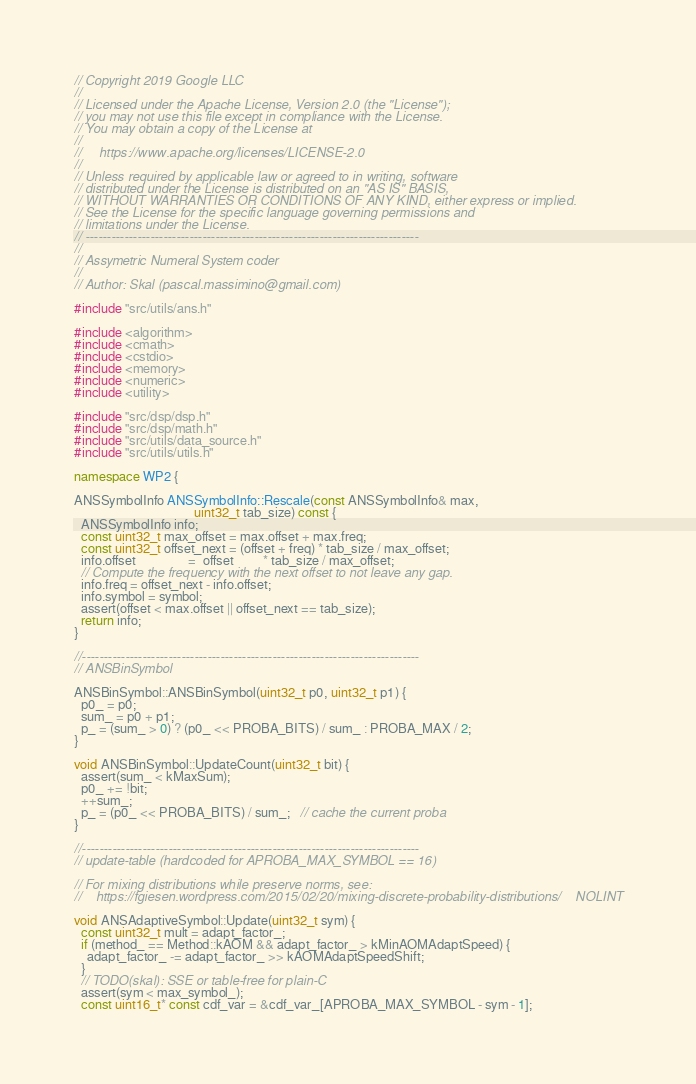<code> <loc_0><loc_0><loc_500><loc_500><_C++_>// Copyright 2019 Google LLC
//
// Licensed under the Apache License, Version 2.0 (the "License");
// you may not use this file except in compliance with the License.
// You may obtain a copy of the License at
//
//     https://www.apache.org/licenses/LICENSE-2.0
//
// Unless required by applicable law or agreed to in writing, software
// distributed under the License is distributed on an "AS IS" BASIS,
// WITHOUT WARRANTIES OR CONDITIONS OF ANY KIND, either express or implied.
// See the License for the specific language governing permissions and
// limitations under the License.
// -----------------------------------------------------------------------------
//
// Assymetric Numeral System coder
//
// Author: Skal (pascal.massimino@gmail.com)

#include "src/utils/ans.h"

#include <algorithm>
#include <cmath>
#include <cstdio>
#include <memory>
#include <numeric>
#include <utility>

#include "src/dsp/dsp.h"
#include "src/dsp/math.h"
#include "src/utils/data_source.h"
#include "src/utils/utils.h"

namespace WP2 {

ANSSymbolInfo ANSSymbolInfo::Rescale(const ANSSymbolInfo& max,
                                     uint32_t tab_size) const {
  ANSSymbolInfo info;
  const uint32_t max_offset = max.offset + max.freq;
  const uint32_t offset_next = (offset + freq) * tab_size / max_offset;
  info.offset                =  offset         * tab_size / max_offset;
  // Compute the frequency with the next offset to not leave any gap.
  info.freq = offset_next - info.offset;
  info.symbol = symbol;
  assert(offset < max.offset || offset_next == tab_size);
  return info;
}

//------------------------------------------------------------------------------
// ANSBinSymbol

ANSBinSymbol::ANSBinSymbol(uint32_t p0, uint32_t p1) {
  p0_ = p0;
  sum_ = p0 + p1;
  p_ = (sum_ > 0) ? (p0_ << PROBA_BITS) / sum_ : PROBA_MAX / 2;
}

void ANSBinSymbol::UpdateCount(uint32_t bit) {
  assert(sum_ < kMaxSum);
  p0_ += !bit;
  ++sum_;
  p_ = (p0_ << PROBA_BITS) / sum_;   // cache the current proba
}

//------------------------------------------------------------------------------
// update-table (hardcoded for APROBA_MAX_SYMBOL == 16)

// For mixing distributions while preserve norms, see:
//    https://fgiesen.wordpress.com/2015/02/20/mixing-discrete-probability-distributions/    NOLINT

void ANSAdaptiveSymbol::Update(uint32_t sym) {
  const uint32_t mult = adapt_factor_;
  if (method_ == Method::kAOM && adapt_factor_ > kMinAOMAdaptSpeed) {
    adapt_factor_ -= adapt_factor_ >> kAOMAdaptSpeedShift;
  }
  // TODO(skal): SSE or table-free for plain-C
  assert(sym < max_symbol_);
  const uint16_t* const cdf_var = &cdf_var_[APROBA_MAX_SYMBOL - sym - 1];</code> 